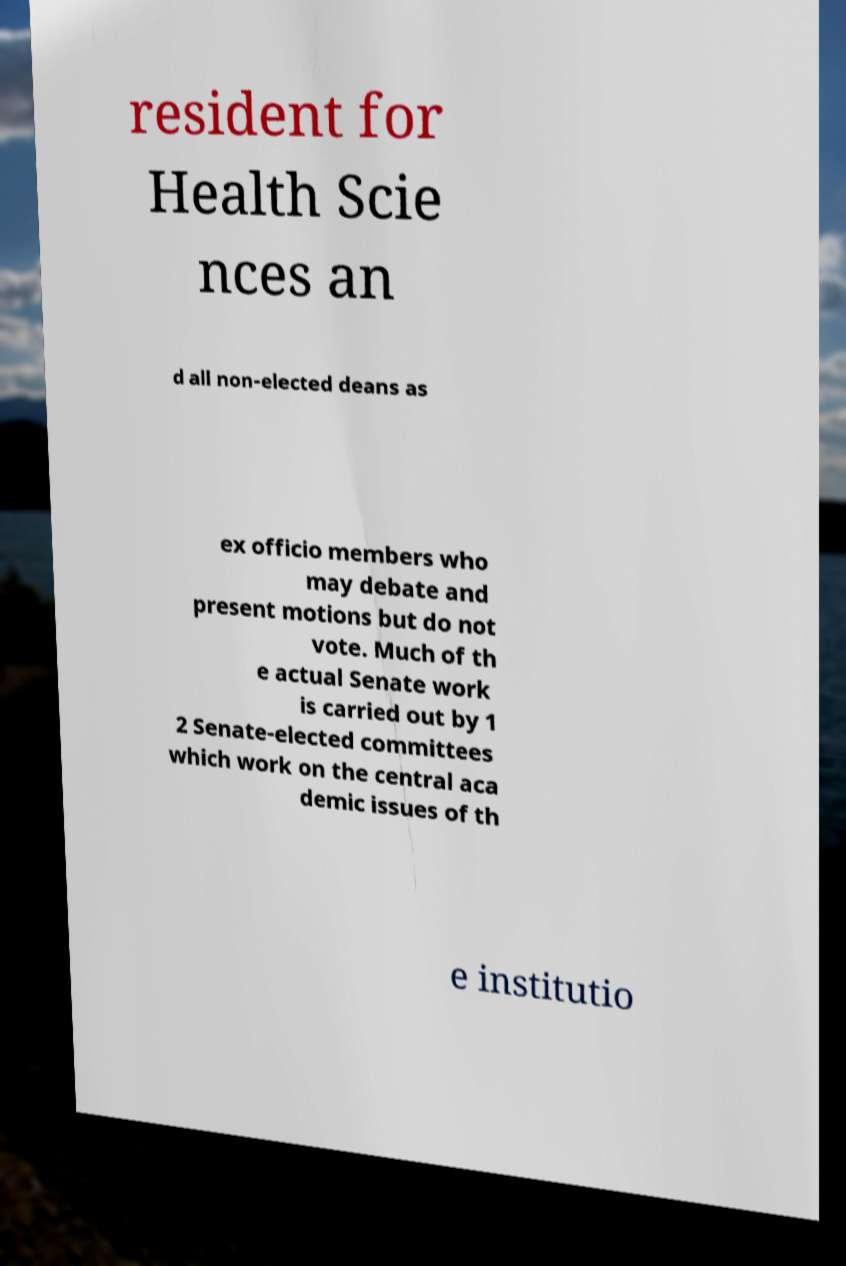Please identify and transcribe the text found in this image. resident for Health Scie nces an d all non-elected deans as ex officio members who may debate and present motions but do not vote. Much of th e actual Senate work is carried out by 1 2 Senate-elected committees which work on the central aca demic issues of th e institutio 